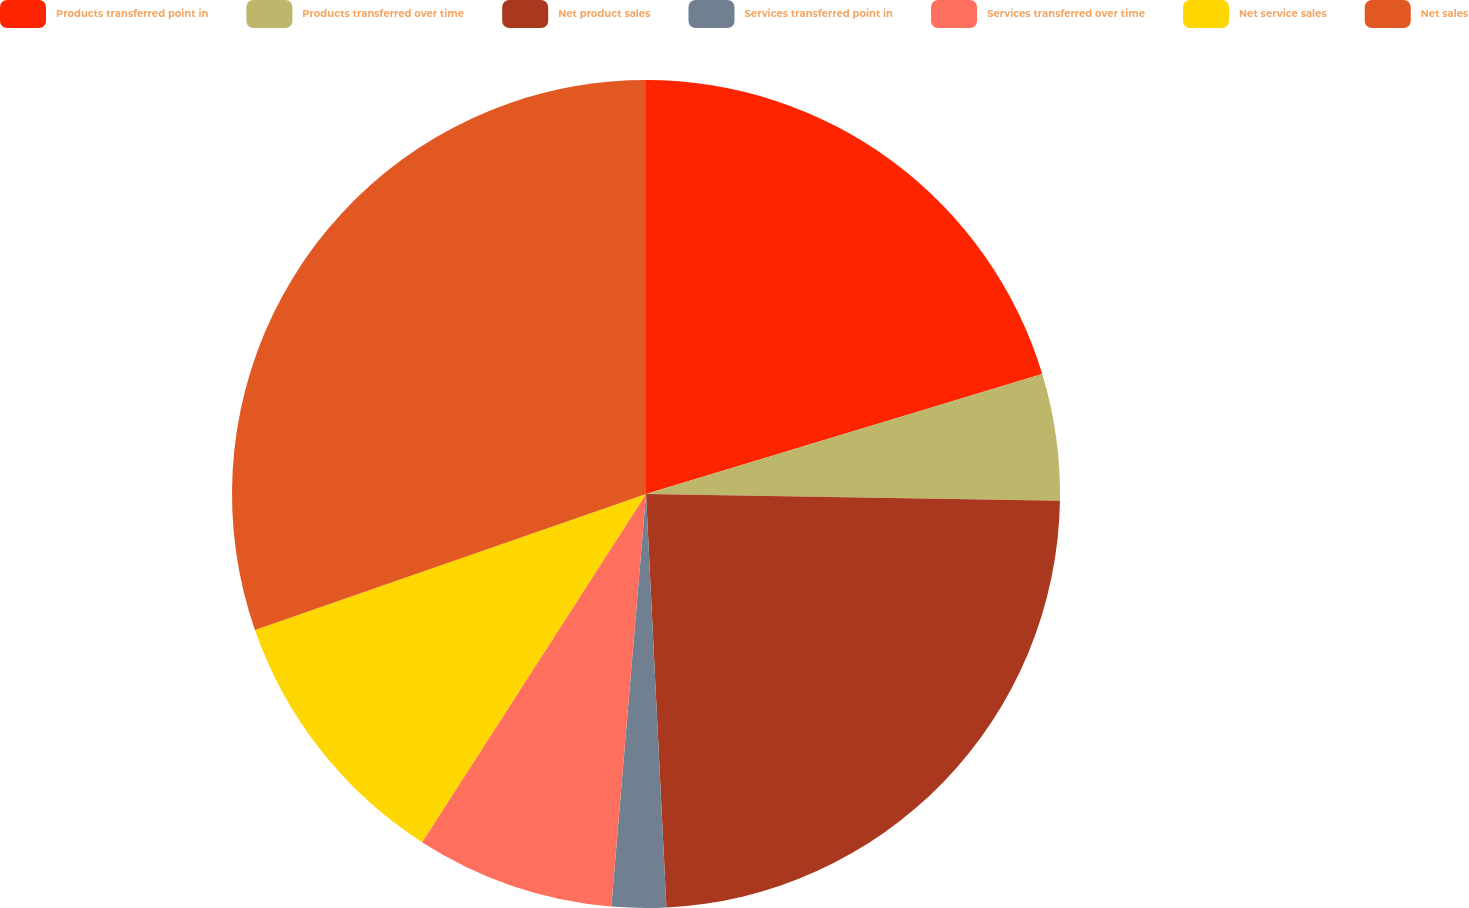<chart> <loc_0><loc_0><loc_500><loc_500><pie_chart><fcel>Products transferred point in<fcel>Products transferred over time<fcel>Net product sales<fcel>Services transferred point in<fcel>Services transferred over time<fcel>Net service sales<fcel>Net sales<nl><fcel>20.32%<fcel>4.94%<fcel>23.95%<fcel>2.12%<fcel>7.76%<fcel>10.58%<fcel>30.32%<nl></chart> 